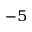Convert formula to latex. <formula><loc_0><loc_0><loc_500><loc_500>^ { - 5 }</formula> 